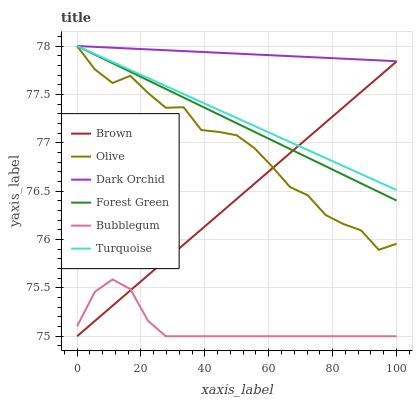Does Bubblegum have the minimum area under the curve?
Answer yes or no. Yes. Does Dark Orchid have the maximum area under the curve?
Answer yes or no. Yes. Does Turquoise have the minimum area under the curve?
Answer yes or no. No. Does Turquoise have the maximum area under the curve?
Answer yes or no. No. Is Dark Orchid the smoothest?
Answer yes or no. Yes. Is Olive the roughest?
Answer yes or no. Yes. Is Turquoise the smoothest?
Answer yes or no. No. Is Turquoise the roughest?
Answer yes or no. No. Does Brown have the lowest value?
Answer yes or no. Yes. Does Turquoise have the lowest value?
Answer yes or no. No. Does Olive have the highest value?
Answer yes or no. Yes. Does Bubblegum have the highest value?
Answer yes or no. No. Is Bubblegum less than Dark Orchid?
Answer yes or no. Yes. Is Turquoise greater than Bubblegum?
Answer yes or no. Yes. Does Olive intersect Dark Orchid?
Answer yes or no. Yes. Is Olive less than Dark Orchid?
Answer yes or no. No. Is Olive greater than Dark Orchid?
Answer yes or no. No. Does Bubblegum intersect Dark Orchid?
Answer yes or no. No. 